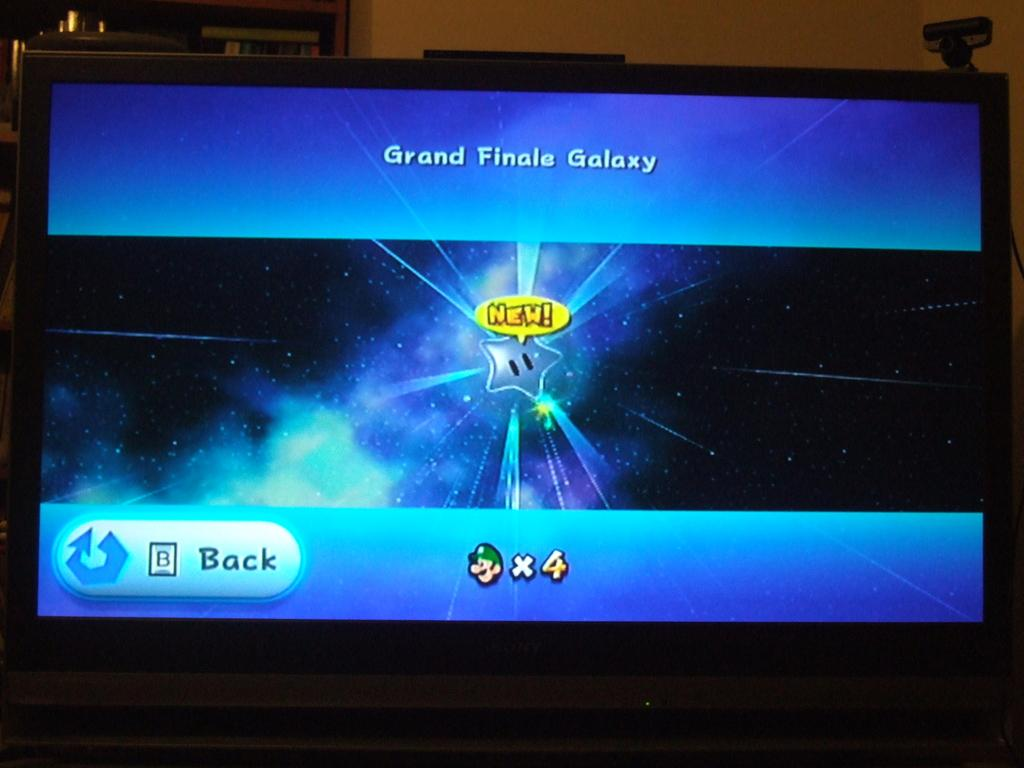<image>
Create a compact narrative representing the image presented. TV screen says Grand Finale Galaxy NEW! with a star galaxy in the background 